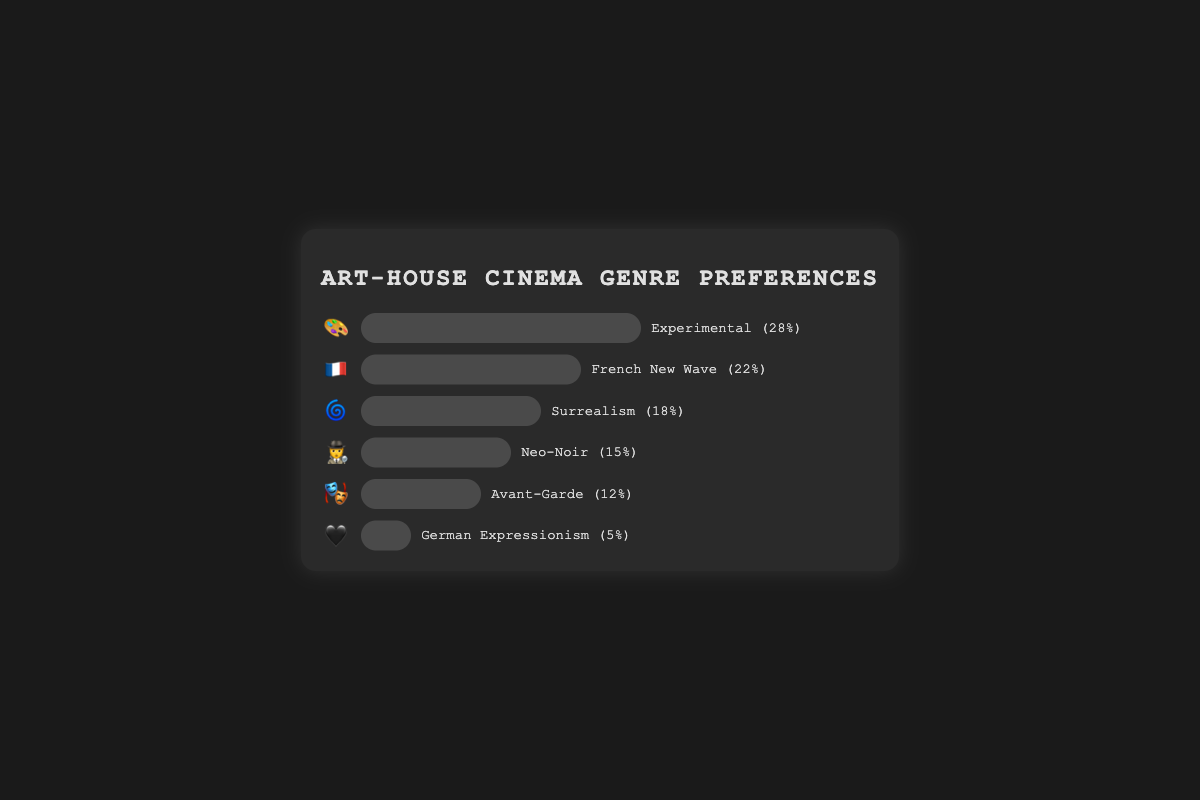What is the most preferred genre among art-house cinema-goers? The most preferred genre is the one with the highest percentage. By looking at the bars, the "Experimental" genre has the longest bar, corresponding to 28%.
Answer: Experimental Which genre has the least preference? The genre with the smallest percentage has the least preference. The shortest bar is for "German Expressionism," which is 5%.
Answer: German Expressionism What is the total percentage of preferences for French New Wave and Surrealism combined? Add the percentages of French New Wave (22%) and Surrealism (18%): 22 + 18 = 40%.
Answer: 40% How much more popular is the Experimental genre compared to the Neo-Noir genre? Subtract the percentage of the Neo-Noir genre (15%) from the Experimental genre (28%): 28 - 15 = 13%.
Answer: 13% Rank the genres from most preferred to least preferred based on the figure. The order from most preferred to least preferred can be determined by ordering the percentages: Experimental (28%), French New Wave (22%), Surrealism (18%), Neo-Noir (15%), Avant-Garde (12%), German Expressionism (5%).
Answer: Experimental, French New Wave, Surrealism, Neo-Noir, Avant-Garde, German Expressionism Which genres have a preference percentage higher than 20%? The genres with a preference percentage higher than 20% are Experimental (28%) and French New Wave (22%).
Answer: Experimental, French New Wave What is the combined percentage of genres preferred by at least 15% of art-house cinema-goers? Combine the percentages for genres with at least 15%: Experimental (28%), French New Wave (22%), Surrealism (18%), and Neo-Noir (15%). Summing these gives: 28 + 22 + 18 + 15 = 83%.
Answer: 83% By how much does Avant-Garde lag behind Neo-Noir in terms of preference? Subtract the percentage of Avant-Garde (12%) from Neo-Noir (15%): 15 - 12 = 3%.
Answer: 3% What percentage of cinema-goers prefer any of the genres other than Experimental? Subtract the percentage of Experimental (28%) from 100%: 100 - 28 = 72%.
Answer: 72% 